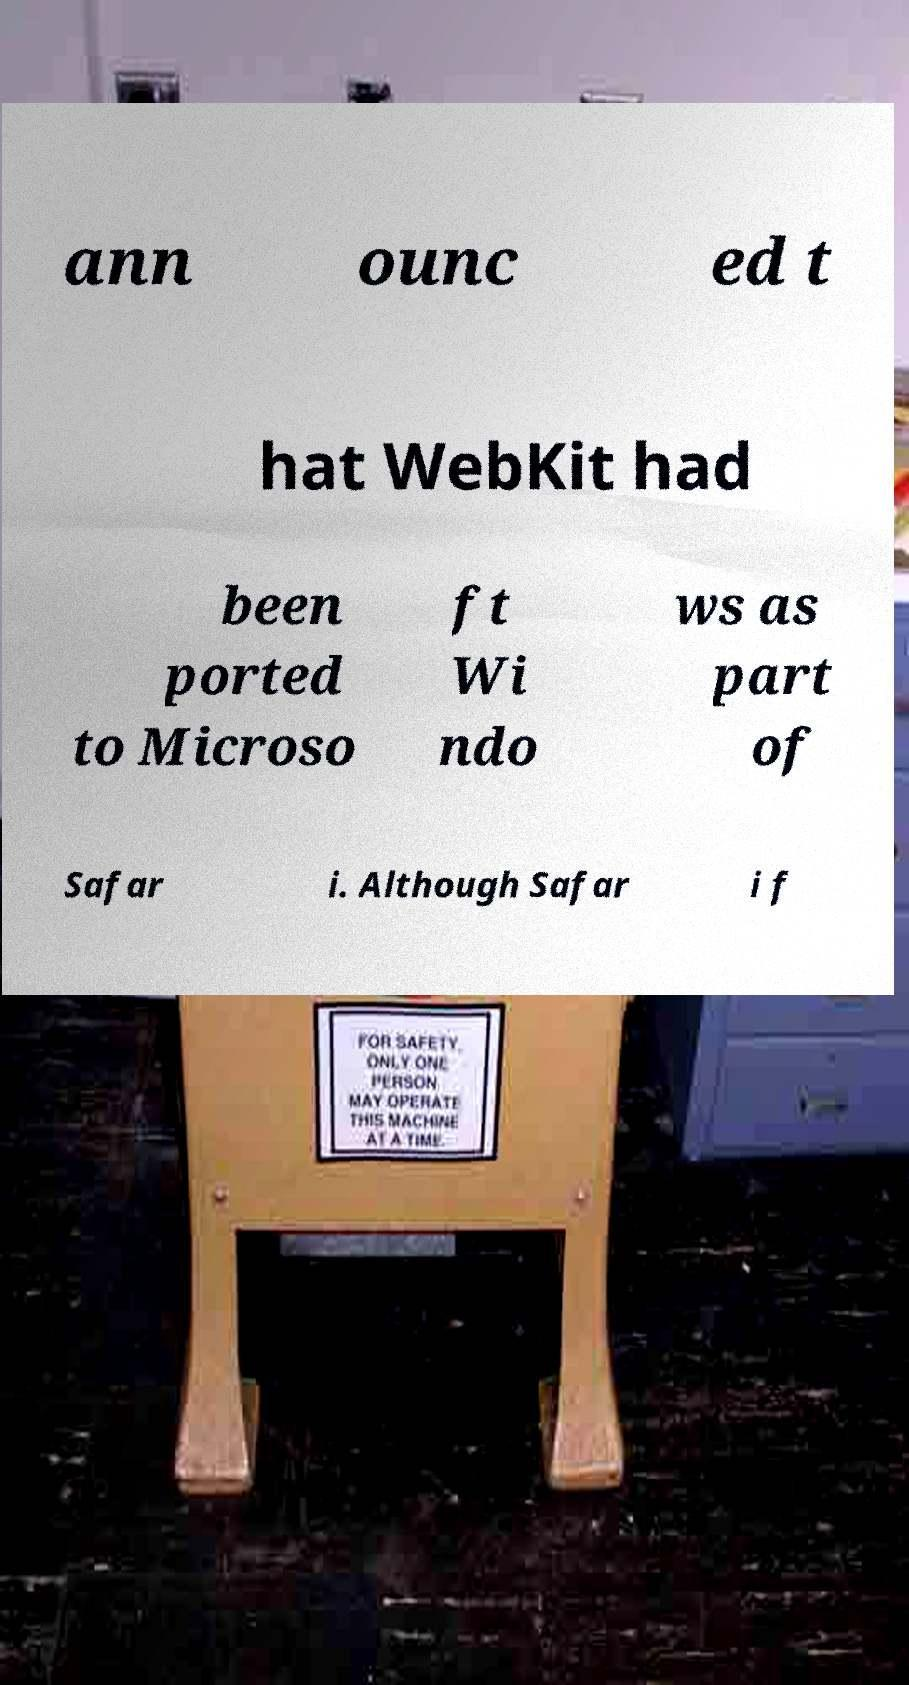Could you extract and type out the text from this image? ann ounc ed t hat WebKit had been ported to Microso ft Wi ndo ws as part of Safar i. Although Safar i f 